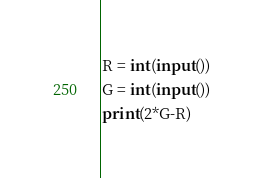<code> <loc_0><loc_0><loc_500><loc_500><_Python_>R = int(input())
G = int(input())
print(2*G-R)</code> 